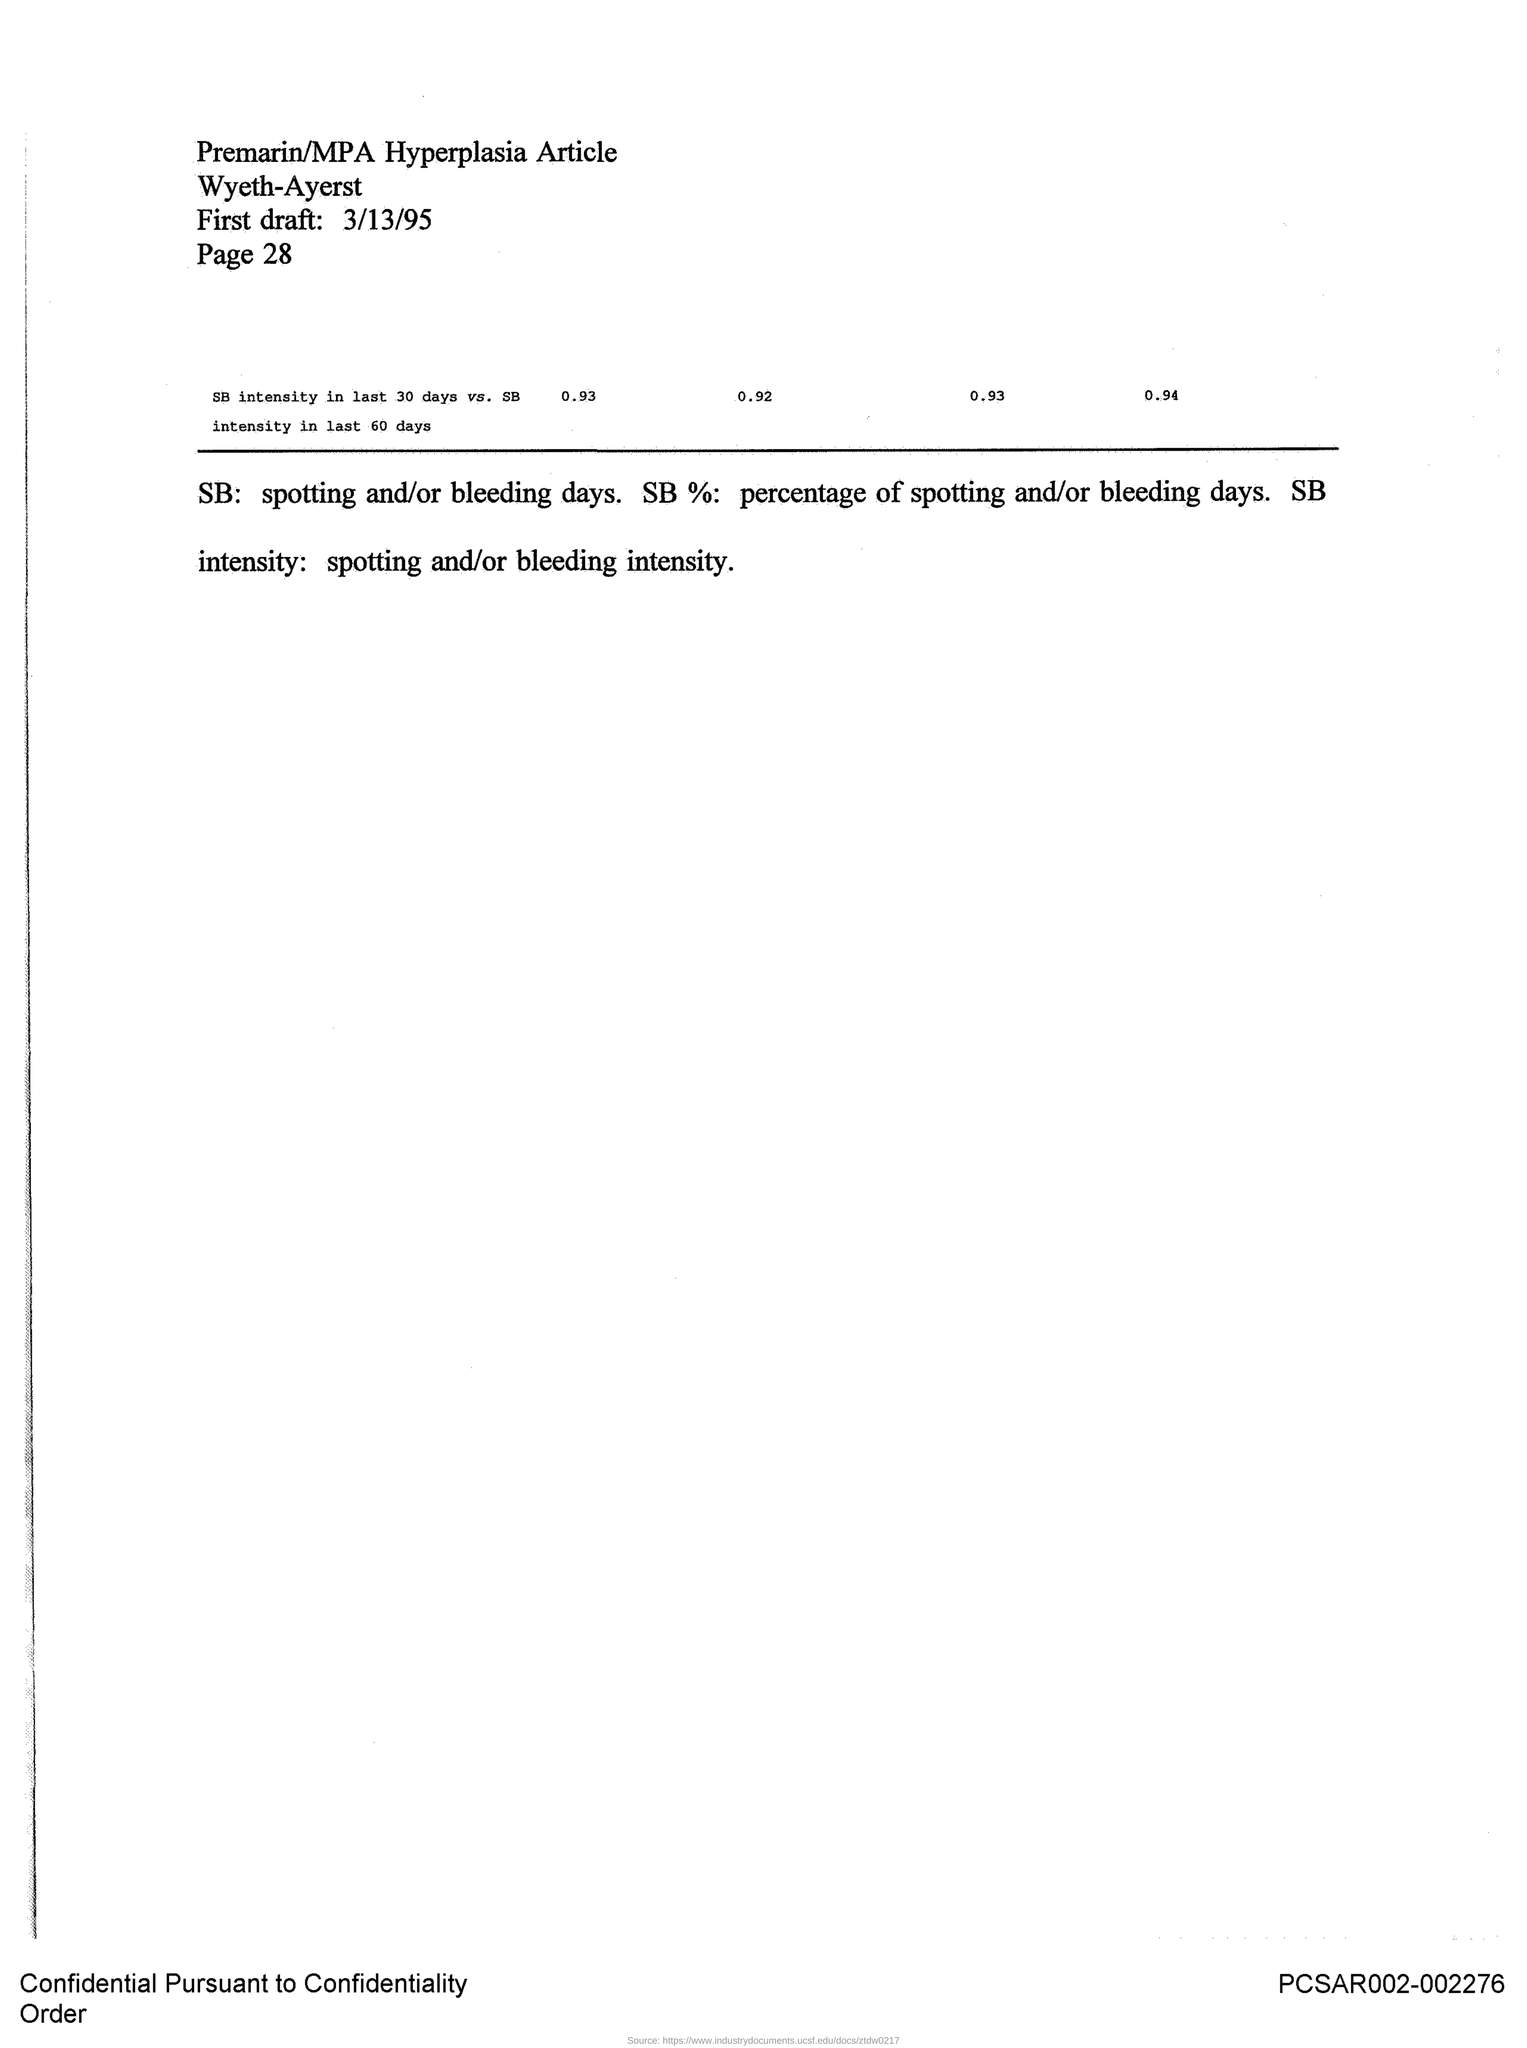List a handful of essential elements in this visual. The first draft was drafted on March 13, 1995. The article is titled 'Premarin/MPA Hyperplasia.' 